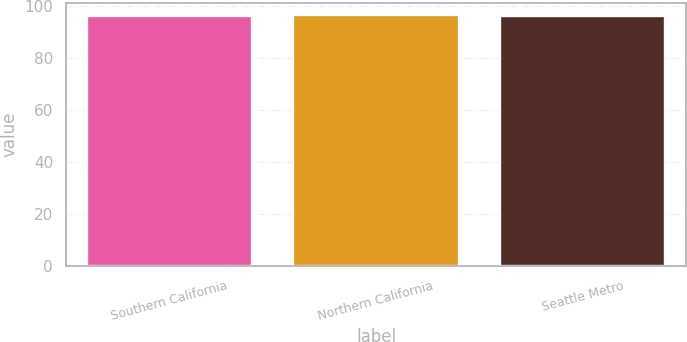<chart> <loc_0><loc_0><loc_500><loc_500><bar_chart><fcel>Southern California<fcel>Northern California<fcel>Seattle Metro<nl><fcel>96.2<fcel>96.3<fcel>96.21<nl></chart> 